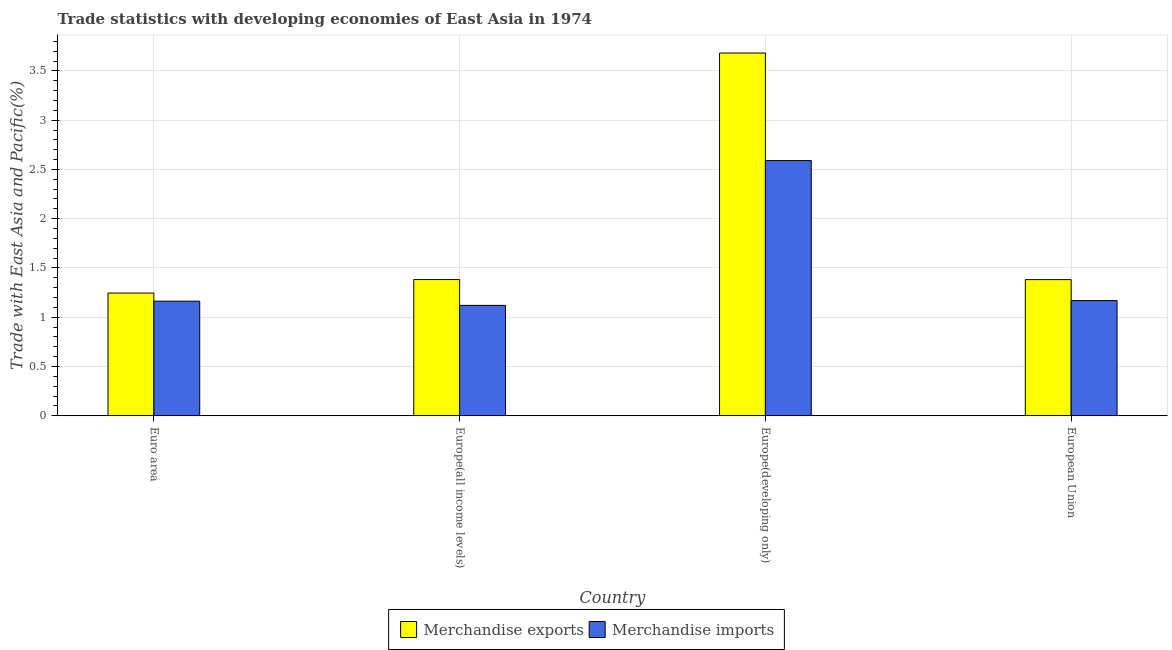How many groups of bars are there?
Keep it short and to the point. 4. Are the number of bars per tick equal to the number of legend labels?
Your answer should be compact. Yes. How many bars are there on the 3rd tick from the left?
Offer a terse response. 2. What is the merchandise imports in Europe(developing only)?
Make the answer very short. 2.59. Across all countries, what is the maximum merchandise exports?
Your answer should be compact. 3.68. Across all countries, what is the minimum merchandise imports?
Your response must be concise. 1.12. In which country was the merchandise imports maximum?
Provide a succinct answer. Europe(developing only). In which country was the merchandise imports minimum?
Your answer should be compact. Europe(all income levels). What is the total merchandise exports in the graph?
Offer a terse response. 7.69. What is the difference between the merchandise exports in Euro area and that in Europe(all income levels)?
Your response must be concise. -0.14. What is the difference between the merchandise exports in Europe(all income levels) and the merchandise imports in Europe(developing only)?
Offer a terse response. -1.21. What is the average merchandise imports per country?
Give a very brief answer. 1.51. What is the difference between the merchandise exports and merchandise imports in Europe(developing only)?
Your answer should be compact. 1.09. What is the ratio of the merchandise imports in Europe(developing only) to that in European Union?
Offer a very short reply. 2.22. What is the difference between the highest and the second highest merchandise exports?
Keep it short and to the point. 2.3. What is the difference between the highest and the lowest merchandise exports?
Give a very brief answer. 2.44. In how many countries, is the merchandise imports greater than the average merchandise imports taken over all countries?
Your response must be concise. 1. What does the 1st bar from the left in European Union represents?
Your answer should be very brief. Merchandise exports. How many bars are there?
Provide a succinct answer. 8. How many countries are there in the graph?
Provide a short and direct response. 4. Does the graph contain any zero values?
Offer a terse response. No. Where does the legend appear in the graph?
Provide a short and direct response. Bottom center. How are the legend labels stacked?
Offer a terse response. Horizontal. What is the title of the graph?
Keep it short and to the point. Trade statistics with developing economies of East Asia in 1974. What is the label or title of the X-axis?
Provide a succinct answer. Country. What is the label or title of the Y-axis?
Provide a short and direct response. Trade with East Asia and Pacific(%). What is the Trade with East Asia and Pacific(%) of Merchandise exports in Euro area?
Provide a short and direct response. 1.25. What is the Trade with East Asia and Pacific(%) of Merchandise imports in Euro area?
Your response must be concise. 1.16. What is the Trade with East Asia and Pacific(%) in Merchandise exports in Europe(all income levels)?
Offer a very short reply. 1.38. What is the Trade with East Asia and Pacific(%) in Merchandise imports in Europe(all income levels)?
Provide a succinct answer. 1.12. What is the Trade with East Asia and Pacific(%) in Merchandise exports in Europe(developing only)?
Make the answer very short. 3.68. What is the Trade with East Asia and Pacific(%) in Merchandise imports in Europe(developing only)?
Offer a very short reply. 2.59. What is the Trade with East Asia and Pacific(%) in Merchandise exports in European Union?
Provide a succinct answer. 1.38. What is the Trade with East Asia and Pacific(%) in Merchandise imports in European Union?
Provide a succinct answer. 1.17. Across all countries, what is the maximum Trade with East Asia and Pacific(%) of Merchandise exports?
Make the answer very short. 3.68. Across all countries, what is the maximum Trade with East Asia and Pacific(%) of Merchandise imports?
Offer a very short reply. 2.59. Across all countries, what is the minimum Trade with East Asia and Pacific(%) in Merchandise exports?
Make the answer very short. 1.25. Across all countries, what is the minimum Trade with East Asia and Pacific(%) in Merchandise imports?
Your answer should be very brief. 1.12. What is the total Trade with East Asia and Pacific(%) in Merchandise exports in the graph?
Your response must be concise. 7.69. What is the total Trade with East Asia and Pacific(%) of Merchandise imports in the graph?
Keep it short and to the point. 6.04. What is the difference between the Trade with East Asia and Pacific(%) of Merchandise exports in Euro area and that in Europe(all income levels)?
Ensure brevity in your answer.  -0.14. What is the difference between the Trade with East Asia and Pacific(%) of Merchandise imports in Euro area and that in Europe(all income levels)?
Keep it short and to the point. 0.04. What is the difference between the Trade with East Asia and Pacific(%) of Merchandise exports in Euro area and that in Europe(developing only)?
Ensure brevity in your answer.  -2.44. What is the difference between the Trade with East Asia and Pacific(%) in Merchandise imports in Euro area and that in Europe(developing only)?
Ensure brevity in your answer.  -1.43. What is the difference between the Trade with East Asia and Pacific(%) of Merchandise exports in Euro area and that in European Union?
Give a very brief answer. -0.14. What is the difference between the Trade with East Asia and Pacific(%) in Merchandise imports in Euro area and that in European Union?
Ensure brevity in your answer.  -0.01. What is the difference between the Trade with East Asia and Pacific(%) of Merchandise exports in Europe(all income levels) and that in Europe(developing only)?
Give a very brief answer. -2.3. What is the difference between the Trade with East Asia and Pacific(%) in Merchandise imports in Europe(all income levels) and that in Europe(developing only)?
Make the answer very short. -1.47. What is the difference between the Trade with East Asia and Pacific(%) of Merchandise exports in Europe(all income levels) and that in European Union?
Provide a succinct answer. 0. What is the difference between the Trade with East Asia and Pacific(%) of Merchandise imports in Europe(all income levels) and that in European Union?
Your response must be concise. -0.05. What is the difference between the Trade with East Asia and Pacific(%) of Merchandise exports in Europe(developing only) and that in European Union?
Your answer should be compact. 2.3. What is the difference between the Trade with East Asia and Pacific(%) in Merchandise imports in Europe(developing only) and that in European Union?
Make the answer very short. 1.42. What is the difference between the Trade with East Asia and Pacific(%) in Merchandise exports in Euro area and the Trade with East Asia and Pacific(%) in Merchandise imports in Europe(all income levels)?
Your answer should be very brief. 0.13. What is the difference between the Trade with East Asia and Pacific(%) of Merchandise exports in Euro area and the Trade with East Asia and Pacific(%) of Merchandise imports in Europe(developing only)?
Make the answer very short. -1.34. What is the difference between the Trade with East Asia and Pacific(%) in Merchandise exports in Euro area and the Trade with East Asia and Pacific(%) in Merchandise imports in European Union?
Your response must be concise. 0.08. What is the difference between the Trade with East Asia and Pacific(%) in Merchandise exports in Europe(all income levels) and the Trade with East Asia and Pacific(%) in Merchandise imports in Europe(developing only)?
Provide a short and direct response. -1.21. What is the difference between the Trade with East Asia and Pacific(%) of Merchandise exports in Europe(all income levels) and the Trade with East Asia and Pacific(%) of Merchandise imports in European Union?
Offer a terse response. 0.21. What is the difference between the Trade with East Asia and Pacific(%) in Merchandise exports in Europe(developing only) and the Trade with East Asia and Pacific(%) in Merchandise imports in European Union?
Make the answer very short. 2.51. What is the average Trade with East Asia and Pacific(%) in Merchandise exports per country?
Make the answer very short. 1.92. What is the average Trade with East Asia and Pacific(%) in Merchandise imports per country?
Your answer should be very brief. 1.51. What is the difference between the Trade with East Asia and Pacific(%) of Merchandise exports and Trade with East Asia and Pacific(%) of Merchandise imports in Euro area?
Make the answer very short. 0.08. What is the difference between the Trade with East Asia and Pacific(%) of Merchandise exports and Trade with East Asia and Pacific(%) of Merchandise imports in Europe(all income levels)?
Your answer should be very brief. 0.26. What is the difference between the Trade with East Asia and Pacific(%) of Merchandise exports and Trade with East Asia and Pacific(%) of Merchandise imports in Europe(developing only)?
Give a very brief answer. 1.09. What is the difference between the Trade with East Asia and Pacific(%) in Merchandise exports and Trade with East Asia and Pacific(%) in Merchandise imports in European Union?
Offer a terse response. 0.21. What is the ratio of the Trade with East Asia and Pacific(%) in Merchandise exports in Euro area to that in Europe(all income levels)?
Your answer should be very brief. 0.9. What is the ratio of the Trade with East Asia and Pacific(%) of Merchandise imports in Euro area to that in Europe(all income levels)?
Ensure brevity in your answer.  1.04. What is the ratio of the Trade with East Asia and Pacific(%) in Merchandise exports in Euro area to that in Europe(developing only)?
Provide a succinct answer. 0.34. What is the ratio of the Trade with East Asia and Pacific(%) of Merchandise imports in Euro area to that in Europe(developing only)?
Give a very brief answer. 0.45. What is the ratio of the Trade with East Asia and Pacific(%) of Merchandise exports in Euro area to that in European Union?
Keep it short and to the point. 0.9. What is the ratio of the Trade with East Asia and Pacific(%) of Merchandise exports in Europe(all income levels) to that in Europe(developing only)?
Keep it short and to the point. 0.38. What is the ratio of the Trade with East Asia and Pacific(%) of Merchandise imports in Europe(all income levels) to that in Europe(developing only)?
Your response must be concise. 0.43. What is the ratio of the Trade with East Asia and Pacific(%) in Merchandise exports in Europe(all income levels) to that in European Union?
Your response must be concise. 1. What is the ratio of the Trade with East Asia and Pacific(%) in Merchandise imports in Europe(all income levels) to that in European Union?
Give a very brief answer. 0.96. What is the ratio of the Trade with East Asia and Pacific(%) in Merchandise exports in Europe(developing only) to that in European Union?
Keep it short and to the point. 2.66. What is the ratio of the Trade with East Asia and Pacific(%) in Merchandise imports in Europe(developing only) to that in European Union?
Provide a succinct answer. 2.22. What is the difference between the highest and the second highest Trade with East Asia and Pacific(%) of Merchandise exports?
Offer a terse response. 2.3. What is the difference between the highest and the second highest Trade with East Asia and Pacific(%) in Merchandise imports?
Ensure brevity in your answer.  1.42. What is the difference between the highest and the lowest Trade with East Asia and Pacific(%) of Merchandise exports?
Offer a very short reply. 2.44. What is the difference between the highest and the lowest Trade with East Asia and Pacific(%) of Merchandise imports?
Your answer should be very brief. 1.47. 